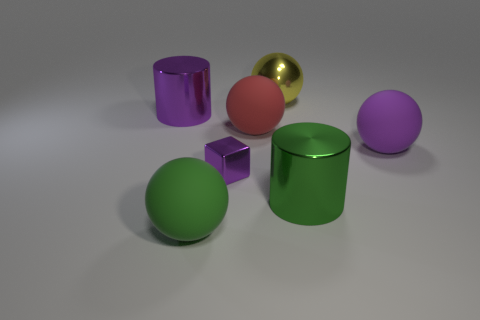Could you describe the lighting set up that might be used to create such an image? The image appears to be lit by a diffuse, overhead light source, given the soft shadows under the objects and the subtle highlights on their surfaces. There could also be secondary lighting to illuminate the scene evenly, avoiding harsh shadows. 